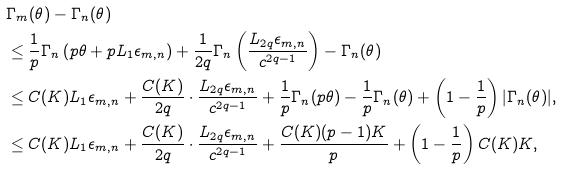<formula> <loc_0><loc_0><loc_500><loc_500>& \Gamma _ { m } ( \theta ) - \Gamma _ { n } ( \theta ) \\ & \leq \frac { 1 } { p } \Gamma _ { n } \left ( p \theta + p L _ { 1 } \epsilon _ { m , n } \right ) + \frac { 1 } { 2 q } \Gamma _ { n } \left ( \frac { L _ { 2 q } \epsilon _ { m , n } } { c ^ { 2 q - 1 } } \right ) - \Gamma _ { n } ( \theta ) \\ & \leq C ( K ) L _ { 1 } \epsilon _ { m , n } + \frac { C ( K ) } { 2 q } \cdot \frac { L _ { 2 q } \epsilon _ { m , n } } { c ^ { 2 q - 1 } } + \frac { 1 } { p } \Gamma _ { n } ( p \theta ) - \frac { 1 } { p } \Gamma _ { n } ( \theta ) + \left ( 1 - \frac { 1 } { p } \right ) | \Gamma _ { n } ( \theta ) | , \\ & \leq C ( K ) L _ { 1 } \epsilon _ { m , n } + \frac { C ( K ) } { 2 q } \cdot \frac { L _ { 2 q } \epsilon _ { m , n } } { c ^ { 2 q - 1 } } + \frac { C ( K ) ( p - 1 ) K } { p } + \left ( 1 - \frac { 1 } { p } \right ) C ( K ) K ,</formula> 